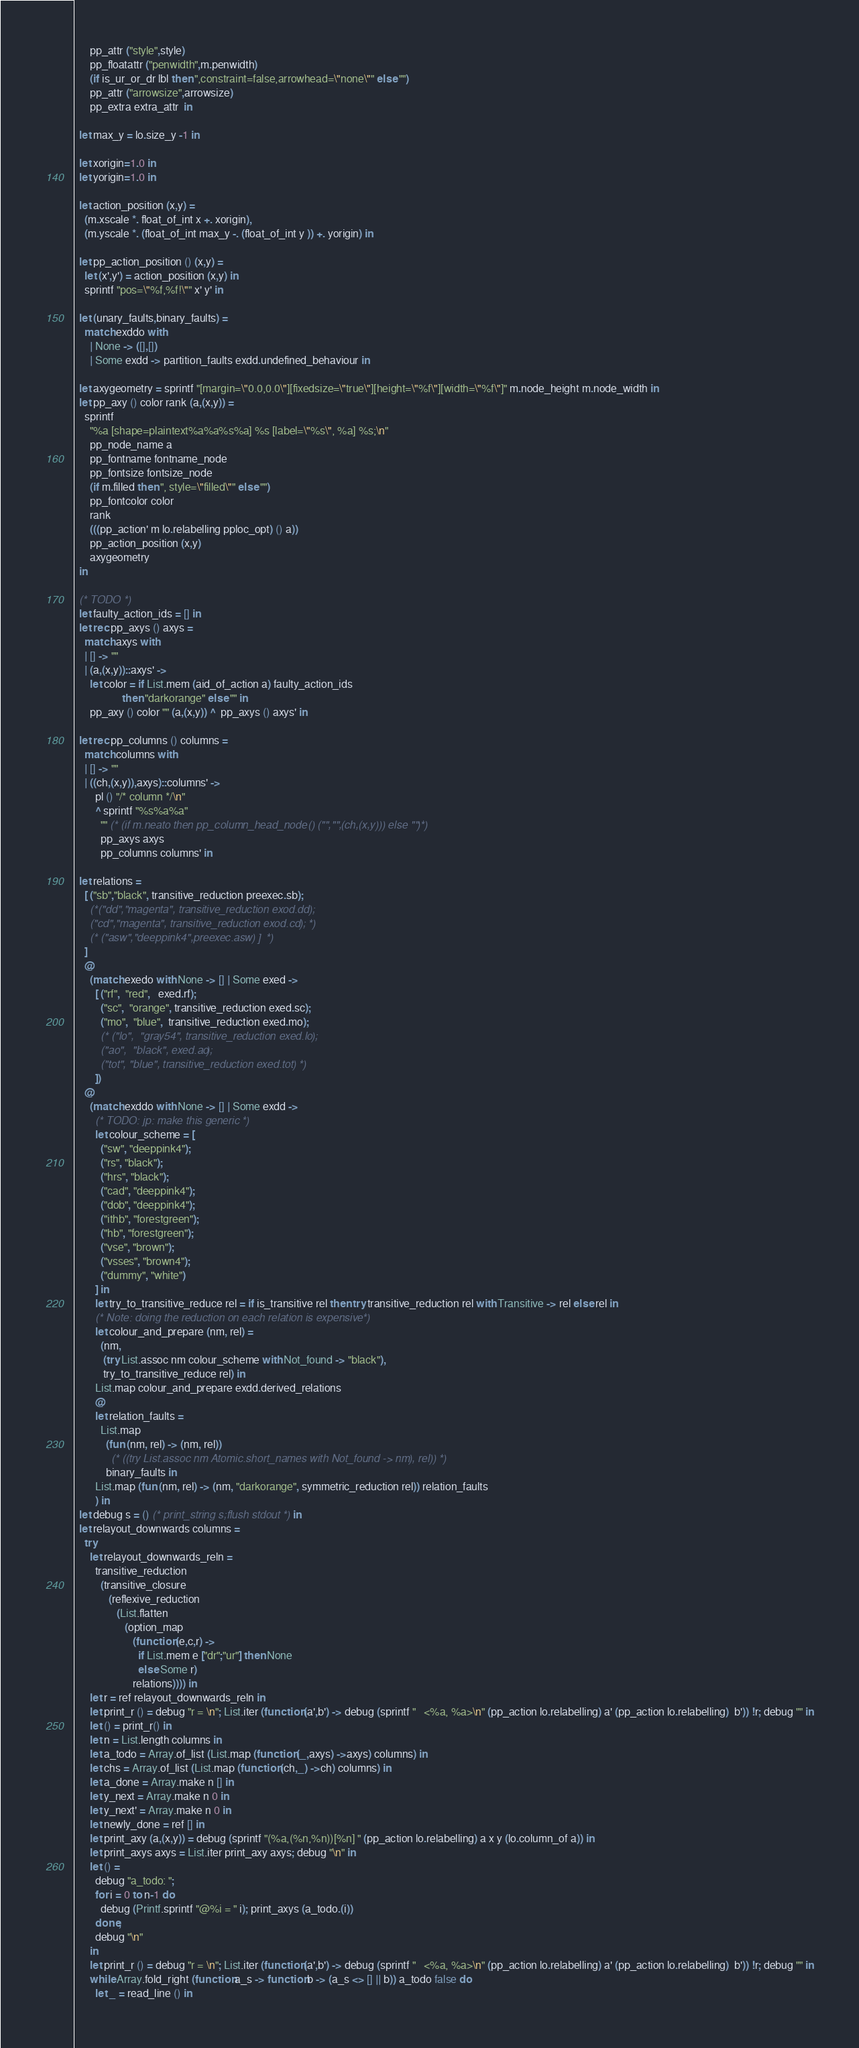Convert code to text. <code><loc_0><loc_0><loc_500><loc_500><_OCaml_>      pp_attr ("style",style)
      pp_floatattr ("penwidth",m.penwidth)
      (if is_ur_or_dr lbl then ",constraint=false,arrowhead=\"none\"" else "")
      pp_attr ("arrowsize",arrowsize)
      pp_extra extra_attr  in

  let max_y = lo.size_y -1 in

  let xorigin=1.0 in
  let yorigin=1.0 in

  let action_position (x,y) =
    (m.xscale *. float_of_int x +. xorigin),
    (m.yscale *. (float_of_int max_y -. (float_of_int y )) +. yorigin) in

  let pp_action_position () (x,y) =
    let (x',y') = action_position (x,y) in
    sprintf "pos=\"%f,%f!\"" x' y' in

  let (unary_faults,binary_faults) =
    match exddo with
      | None -> ([],[])
      | Some exdd -> partition_faults exdd.undefined_behaviour in

  let axygeometry = sprintf "[margin=\"0.0,0.0\"][fixedsize=\"true\"][height=\"%f\"][width=\"%f\"]" m.node_height m.node_width in
  let pp_axy () color rank (a,(x,y)) =
    sprintf
      "%a [shape=plaintext%a%a%s%a] %s [label=\"%s\", %a] %s;\n"
      pp_node_name a
      pp_fontname fontname_node
      pp_fontsize fontsize_node
      (if m.filled then ", style=\"filled\"" else "")
      pp_fontcolor color
      rank
      (((pp_action' m lo.relabelling pploc_opt) () a))
      pp_action_position (x,y)
      axygeometry
  in

  (* TODO *)
  let faulty_action_ids = [] in
  let rec pp_axys () axys =
    match axys with
    | [] -> ""
    | (a,(x,y))::axys' ->
      let color = if List.mem (aid_of_action a) faulty_action_ids
                  then "darkorange" else "" in
      pp_axy () color "" (a,(x,y)) ^  pp_axys () axys' in

  let rec pp_columns () columns =
    match columns with
    | [] -> ""
    | ((ch,(x,y)),axys)::columns' ->
        pl () "/* column */\n"
        ^ sprintf "%s%a%a"
          "" (* (if m.neato then pp_column_head_node () ("","",(ch,(x,y))) else "")*)
          pp_axys axys
          pp_columns columns' in

  let relations =
    [ ("sb","black", transitive_reduction preexec.sb);
      (*("dd","magenta", transitive_reduction exod.dd);
      ("cd","magenta", transitive_reduction exod.cd); *)
      (* ("asw","deeppink4",preexec.asw) ]  *)
    ]
    @
      (match exedo with None -> [] | Some exed ->
        [ ("rf",  "red",   exed.rf);
          ("sc",  "orange", transitive_reduction exed.sc);
          ("mo",  "blue",  transitive_reduction exed.mo);
          (* ("lo",  "gray54", transitive_reduction exed.lo);
          ("ao",  "black", exed.ao);
          ("tot", "blue", transitive_reduction exed.tot) *)
        ])
    @
      (match exddo with None -> [] | Some exdd ->
        (* TODO: jp: make this generic *)
        let colour_scheme = [
          ("sw", "deeppink4");
          ("rs", "black");
          ("hrs", "black");
          ("cad", "deeppink4");
          ("dob", "deeppink4");
          ("ithb", "forestgreen");
          ("hb", "forestgreen");
          ("vse", "brown");
          ("vsses", "brown4");
          ("dummy", "white")
        ] in
        let try_to_transitive_reduce rel = if is_transitive rel then try transitive_reduction rel with Transitive -> rel else rel in
        (* Note: doing the reduction on each relation is expensive *)
        let colour_and_prepare (nm, rel) =
          (nm,
           (try List.assoc nm colour_scheme with Not_found -> "black"),
           try_to_transitive_reduce rel) in
        List.map colour_and_prepare exdd.derived_relations
        @
        let relation_faults =
          List.map
            (fun (nm, rel) -> (nm, rel))
              (* ((try List.assoc nm Atomic.short_names with Not_found -> nm), rel)) *)
            binary_faults in
        List.map (fun (nm, rel) -> (nm, "darkorange", symmetric_reduction rel)) relation_faults
        ) in
  let debug s = () (* print_string s;flush stdout *) in
  let relayout_downwards columns =
    try
      let relayout_downwards_reln =
        transitive_reduction
          (transitive_closure
             (reflexive_reduction
                (List.flatten
                   (option_map
                      (function (e,c,r) ->
                        if List.mem e ["dr";"ur"] then None
                        else Some r)
                      relations)))) in
      let r = ref relayout_downwards_reln in
      let print_r () = debug "r = \n"; List.iter (function (a',b') -> debug (sprintf "   <%a, %a>\n" (pp_action lo.relabelling) a' (pp_action lo.relabelling)  b')) !r; debug "" in
      let () = print_r() in
      let n = List.length columns in
      let a_todo = Array.of_list (List.map (function (_,axys) ->axys) columns) in
      let chs = Array.of_list (List.map (function (ch,_) ->ch) columns) in
      let a_done = Array.make n [] in
      let y_next = Array.make n 0 in
      let y_next' = Array.make n 0 in
      let newly_done = ref [] in
      let print_axy (a,(x,y)) = debug (sprintf "(%a,(%n,%n))[%n] " (pp_action lo.relabelling) a x y (lo.column_of a)) in
      let print_axys axys = List.iter print_axy axys; debug "\n" in
      let () =
        debug "a_todo: ";
        for i = 0 to n-1 do
          debug (Printf.sprintf "@%i = " i); print_axys (a_todo.(i))
        done;
        debug "\n"
      in
      let print_r () = debug "r = \n"; List.iter (function (a',b') -> debug (sprintf "   <%a, %a>\n" (pp_action lo.relabelling) a' (pp_action lo.relabelling)  b')) !r; debug "" in
      while Array.fold_right (function a_s -> function b -> (a_s <> [] || b)) a_todo false do
        let _ = read_line () in</code> 